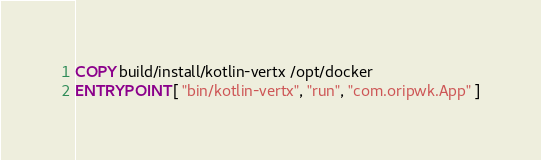<code> <loc_0><loc_0><loc_500><loc_500><_Dockerfile_>COPY build/install/kotlin-vertx /opt/docker
ENTRYPOINT [ "bin/kotlin-vertx", "run", "com.oripwk.App" ]</code> 